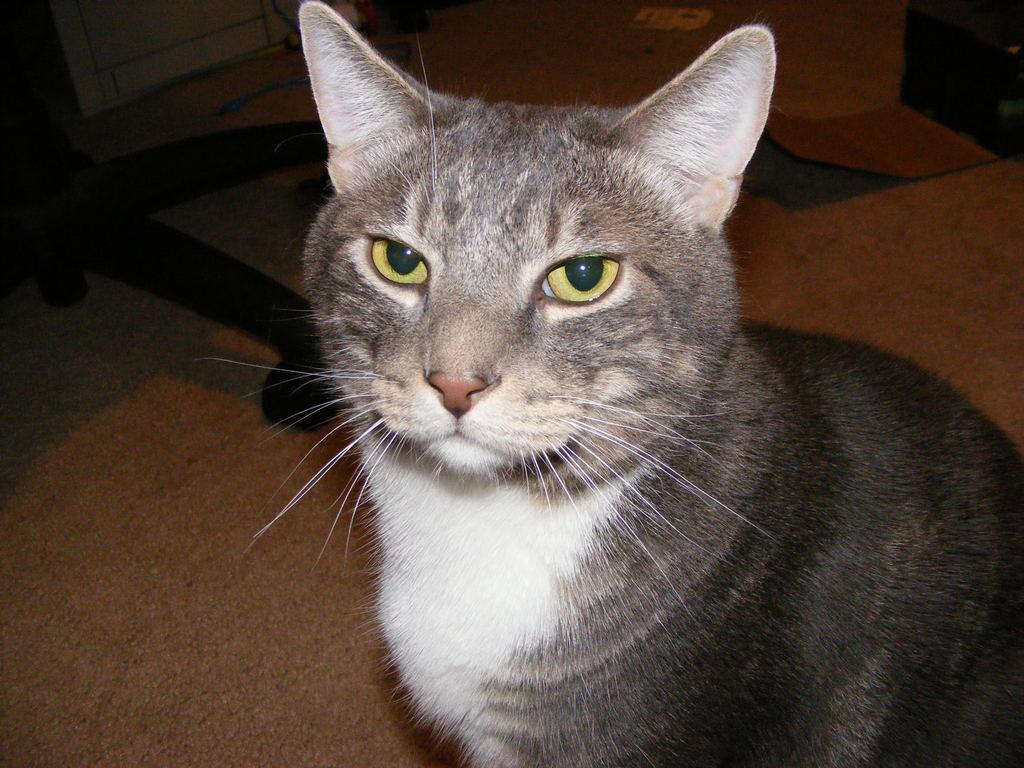What is the main subject of the image? There is a close-up picture of a cat in the image. Where is the cat located in the image? The cat is on the right side of the image. What type of furniture can be seen in the image? There is a chair visible in the image. What type of surface is visible in the image? The floor is visible in the image. What type of sign can be seen in the image? There is no sign present in the image; it features a close-up picture of a cat. Is there a party happening in the image? There is no indication of a party in the image; it only shows a cat and a chair. 